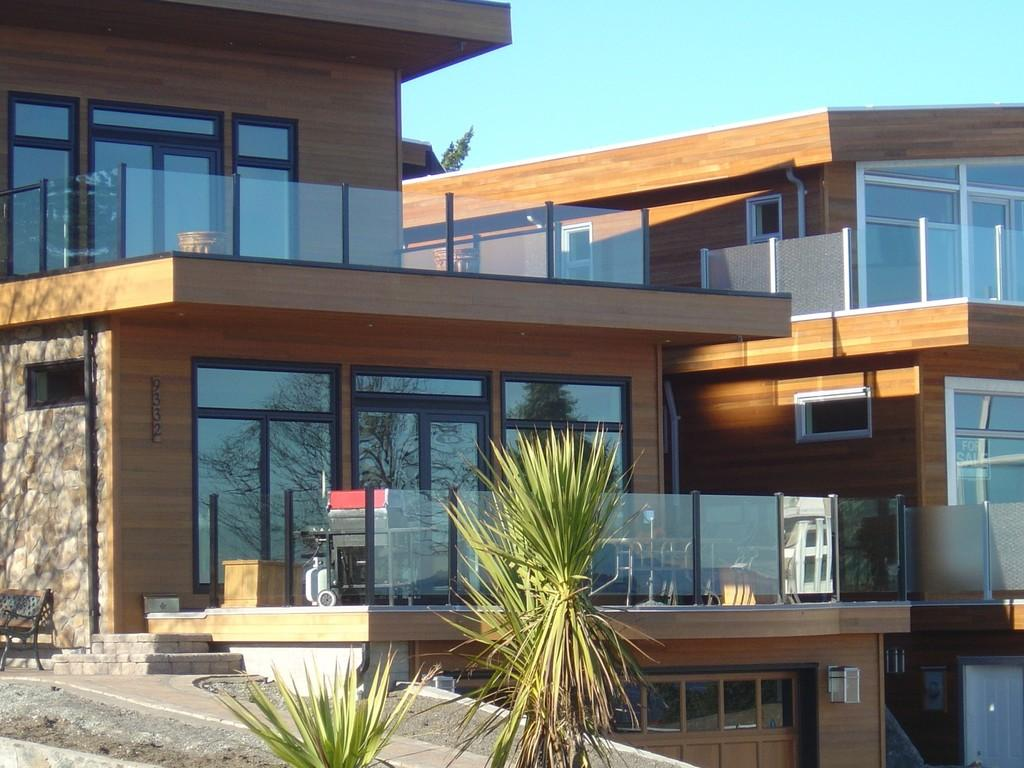What type of living organisms can be seen in the image? Plants can be seen in the image. What type of seating is present in the image? There is a bench in the image. What type of structure is visible in the image? There is a building in the image. What can be seen in the background of the image? Green leaves and the sky are visible in the background of the image. What type of thread is being used by the writer in the image? There is no writer or thread present in the image. How many apples are visible on the plants in the image? There are no apples visible on the plants in the image; only green leaves are mentioned. 